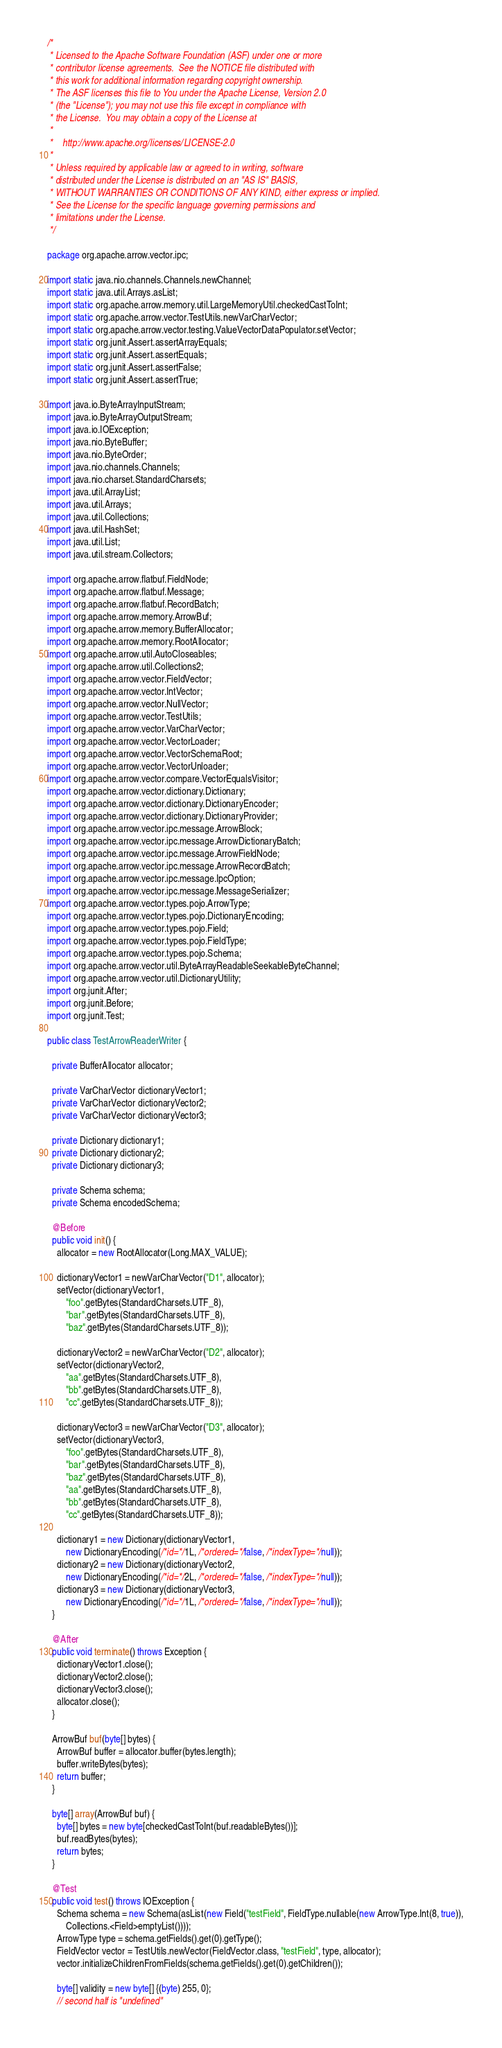<code> <loc_0><loc_0><loc_500><loc_500><_Java_>/*
 * Licensed to the Apache Software Foundation (ASF) under one or more
 * contributor license agreements.  See the NOTICE file distributed with
 * this work for additional information regarding copyright ownership.
 * The ASF licenses this file to You under the Apache License, Version 2.0
 * (the "License"); you may not use this file except in compliance with
 * the License.  You may obtain a copy of the License at
 *
 *    http://www.apache.org/licenses/LICENSE-2.0
 *
 * Unless required by applicable law or agreed to in writing, software
 * distributed under the License is distributed on an "AS IS" BASIS,
 * WITHOUT WARRANTIES OR CONDITIONS OF ANY KIND, either express or implied.
 * See the License for the specific language governing permissions and
 * limitations under the License.
 */

package org.apache.arrow.vector.ipc;

import static java.nio.channels.Channels.newChannel;
import static java.util.Arrays.asList;
import static org.apache.arrow.memory.util.LargeMemoryUtil.checkedCastToInt;
import static org.apache.arrow.vector.TestUtils.newVarCharVector;
import static org.apache.arrow.vector.testing.ValueVectorDataPopulator.setVector;
import static org.junit.Assert.assertArrayEquals;
import static org.junit.Assert.assertEquals;
import static org.junit.Assert.assertFalse;
import static org.junit.Assert.assertTrue;

import java.io.ByteArrayInputStream;
import java.io.ByteArrayOutputStream;
import java.io.IOException;
import java.nio.ByteBuffer;
import java.nio.ByteOrder;
import java.nio.channels.Channels;
import java.nio.charset.StandardCharsets;
import java.util.ArrayList;
import java.util.Arrays;
import java.util.Collections;
import java.util.HashSet;
import java.util.List;
import java.util.stream.Collectors;

import org.apache.arrow.flatbuf.FieldNode;
import org.apache.arrow.flatbuf.Message;
import org.apache.arrow.flatbuf.RecordBatch;
import org.apache.arrow.memory.ArrowBuf;
import org.apache.arrow.memory.BufferAllocator;
import org.apache.arrow.memory.RootAllocator;
import org.apache.arrow.util.AutoCloseables;
import org.apache.arrow.util.Collections2;
import org.apache.arrow.vector.FieldVector;
import org.apache.arrow.vector.IntVector;
import org.apache.arrow.vector.NullVector;
import org.apache.arrow.vector.TestUtils;
import org.apache.arrow.vector.VarCharVector;
import org.apache.arrow.vector.VectorLoader;
import org.apache.arrow.vector.VectorSchemaRoot;
import org.apache.arrow.vector.VectorUnloader;
import org.apache.arrow.vector.compare.VectorEqualsVisitor;
import org.apache.arrow.vector.dictionary.Dictionary;
import org.apache.arrow.vector.dictionary.DictionaryEncoder;
import org.apache.arrow.vector.dictionary.DictionaryProvider;
import org.apache.arrow.vector.ipc.message.ArrowBlock;
import org.apache.arrow.vector.ipc.message.ArrowDictionaryBatch;
import org.apache.arrow.vector.ipc.message.ArrowFieldNode;
import org.apache.arrow.vector.ipc.message.ArrowRecordBatch;
import org.apache.arrow.vector.ipc.message.IpcOption;
import org.apache.arrow.vector.ipc.message.MessageSerializer;
import org.apache.arrow.vector.types.pojo.ArrowType;
import org.apache.arrow.vector.types.pojo.DictionaryEncoding;
import org.apache.arrow.vector.types.pojo.Field;
import org.apache.arrow.vector.types.pojo.FieldType;
import org.apache.arrow.vector.types.pojo.Schema;
import org.apache.arrow.vector.util.ByteArrayReadableSeekableByteChannel;
import org.apache.arrow.vector.util.DictionaryUtility;
import org.junit.After;
import org.junit.Before;
import org.junit.Test;

public class TestArrowReaderWriter {

  private BufferAllocator allocator;

  private VarCharVector dictionaryVector1;
  private VarCharVector dictionaryVector2;
  private VarCharVector dictionaryVector3;

  private Dictionary dictionary1;
  private Dictionary dictionary2;
  private Dictionary dictionary3;

  private Schema schema;
  private Schema encodedSchema;

  @Before
  public void init() {
    allocator = new RootAllocator(Long.MAX_VALUE);

    dictionaryVector1 = newVarCharVector("D1", allocator);
    setVector(dictionaryVector1,
        "foo".getBytes(StandardCharsets.UTF_8),
        "bar".getBytes(StandardCharsets.UTF_8),
        "baz".getBytes(StandardCharsets.UTF_8));

    dictionaryVector2 = newVarCharVector("D2", allocator);
    setVector(dictionaryVector2,
        "aa".getBytes(StandardCharsets.UTF_8),
        "bb".getBytes(StandardCharsets.UTF_8),
        "cc".getBytes(StandardCharsets.UTF_8));

    dictionaryVector3 = newVarCharVector("D3", allocator);
    setVector(dictionaryVector3,
        "foo".getBytes(StandardCharsets.UTF_8),
        "bar".getBytes(StandardCharsets.UTF_8),
        "baz".getBytes(StandardCharsets.UTF_8),
        "aa".getBytes(StandardCharsets.UTF_8),
        "bb".getBytes(StandardCharsets.UTF_8),
        "cc".getBytes(StandardCharsets.UTF_8));

    dictionary1 = new Dictionary(dictionaryVector1,
        new DictionaryEncoding(/*id=*/1L, /*ordered=*/false, /*indexType=*/null));
    dictionary2 = new Dictionary(dictionaryVector2,
        new DictionaryEncoding(/*id=*/2L, /*ordered=*/false, /*indexType=*/null));
    dictionary3 = new Dictionary(dictionaryVector3,
        new DictionaryEncoding(/*id=*/1L, /*ordered=*/false, /*indexType=*/null));
  }

  @After
  public void terminate() throws Exception {
    dictionaryVector1.close();
    dictionaryVector2.close();
    dictionaryVector3.close();
    allocator.close();
  }

  ArrowBuf buf(byte[] bytes) {
    ArrowBuf buffer = allocator.buffer(bytes.length);
    buffer.writeBytes(bytes);
    return buffer;
  }

  byte[] array(ArrowBuf buf) {
    byte[] bytes = new byte[checkedCastToInt(buf.readableBytes())];
    buf.readBytes(bytes);
    return bytes;
  }

  @Test
  public void test() throws IOException {
    Schema schema = new Schema(asList(new Field("testField", FieldType.nullable(new ArrowType.Int(8, true)),
        Collections.<Field>emptyList())));
    ArrowType type = schema.getFields().get(0).getType();
    FieldVector vector = TestUtils.newVector(FieldVector.class, "testField", type, allocator);
    vector.initializeChildrenFromFields(schema.getFields().get(0).getChildren());

    byte[] validity = new byte[] {(byte) 255, 0};
    // second half is "undefined"</code> 